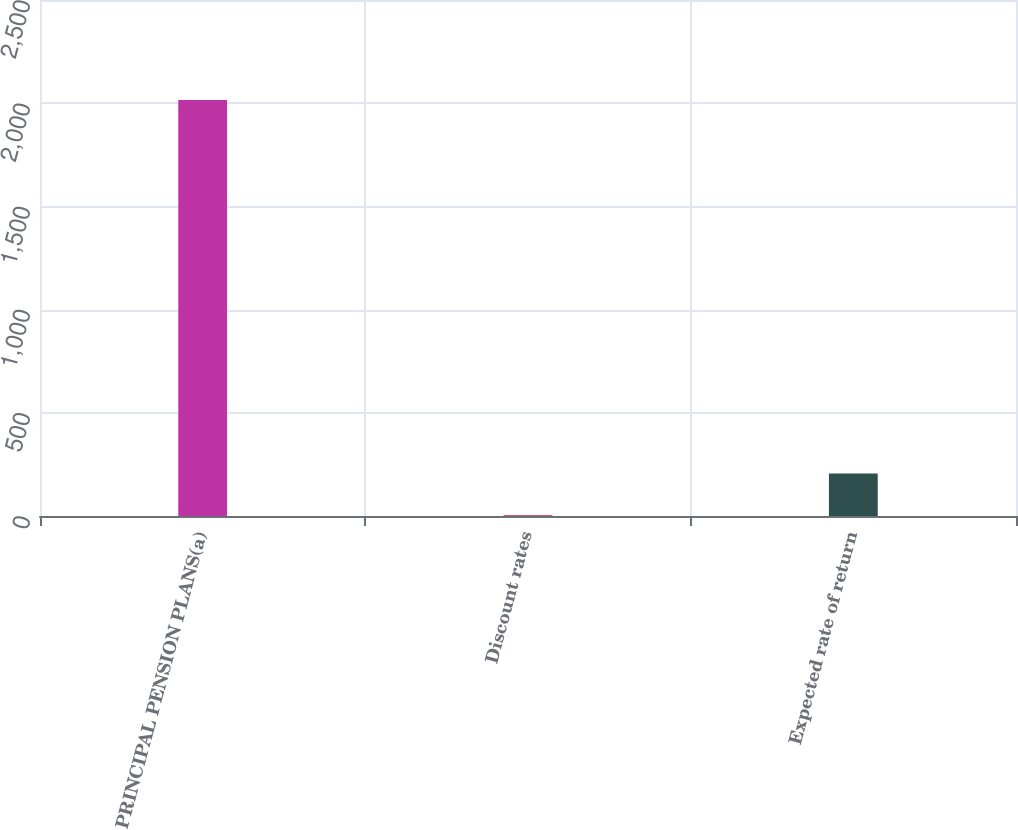Convert chart. <chart><loc_0><loc_0><loc_500><loc_500><bar_chart><fcel>PRINCIPAL PENSION PLANS(a)<fcel>Discount rates<fcel>Expected rate of return<nl><fcel>2016<fcel>4.38<fcel>205.54<nl></chart> 